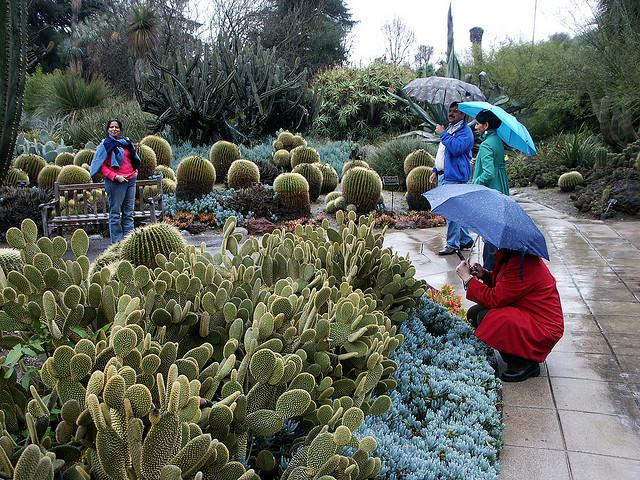What do these plants need very little of? Please explain your reasoning. water. Cacti require little water and can survive long periods of time without it. 